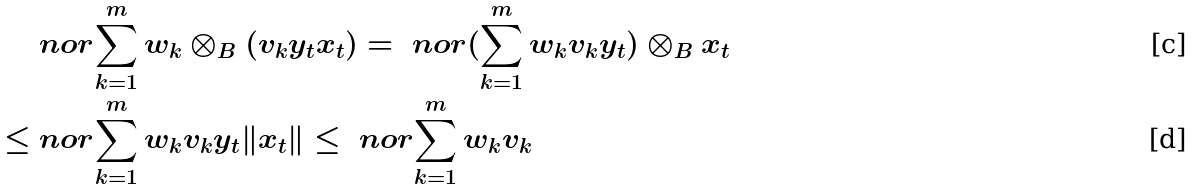Convert formula to latex. <formula><loc_0><loc_0><loc_500><loc_500>& \ n o r { \sum _ { k = 1 } ^ { m } w _ { k } \otimes _ { B } ( v _ { k } y _ { t } x _ { t } ) } = \ n o r { ( \sum _ { k = 1 } ^ { m } w _ { k } v _ { k } y _ { t } ) \otimes _ { B } x _ { t } } \\ \leq & \ n o r { \sum _ { k = 1 } ^ { m } w _ { k } v _ { k } y _ { t } } \| x _ { t } \| \leq \ n o r { \sum _ { k = 1 } ^ { m } w _ { k } v _ { k } }</formula> 